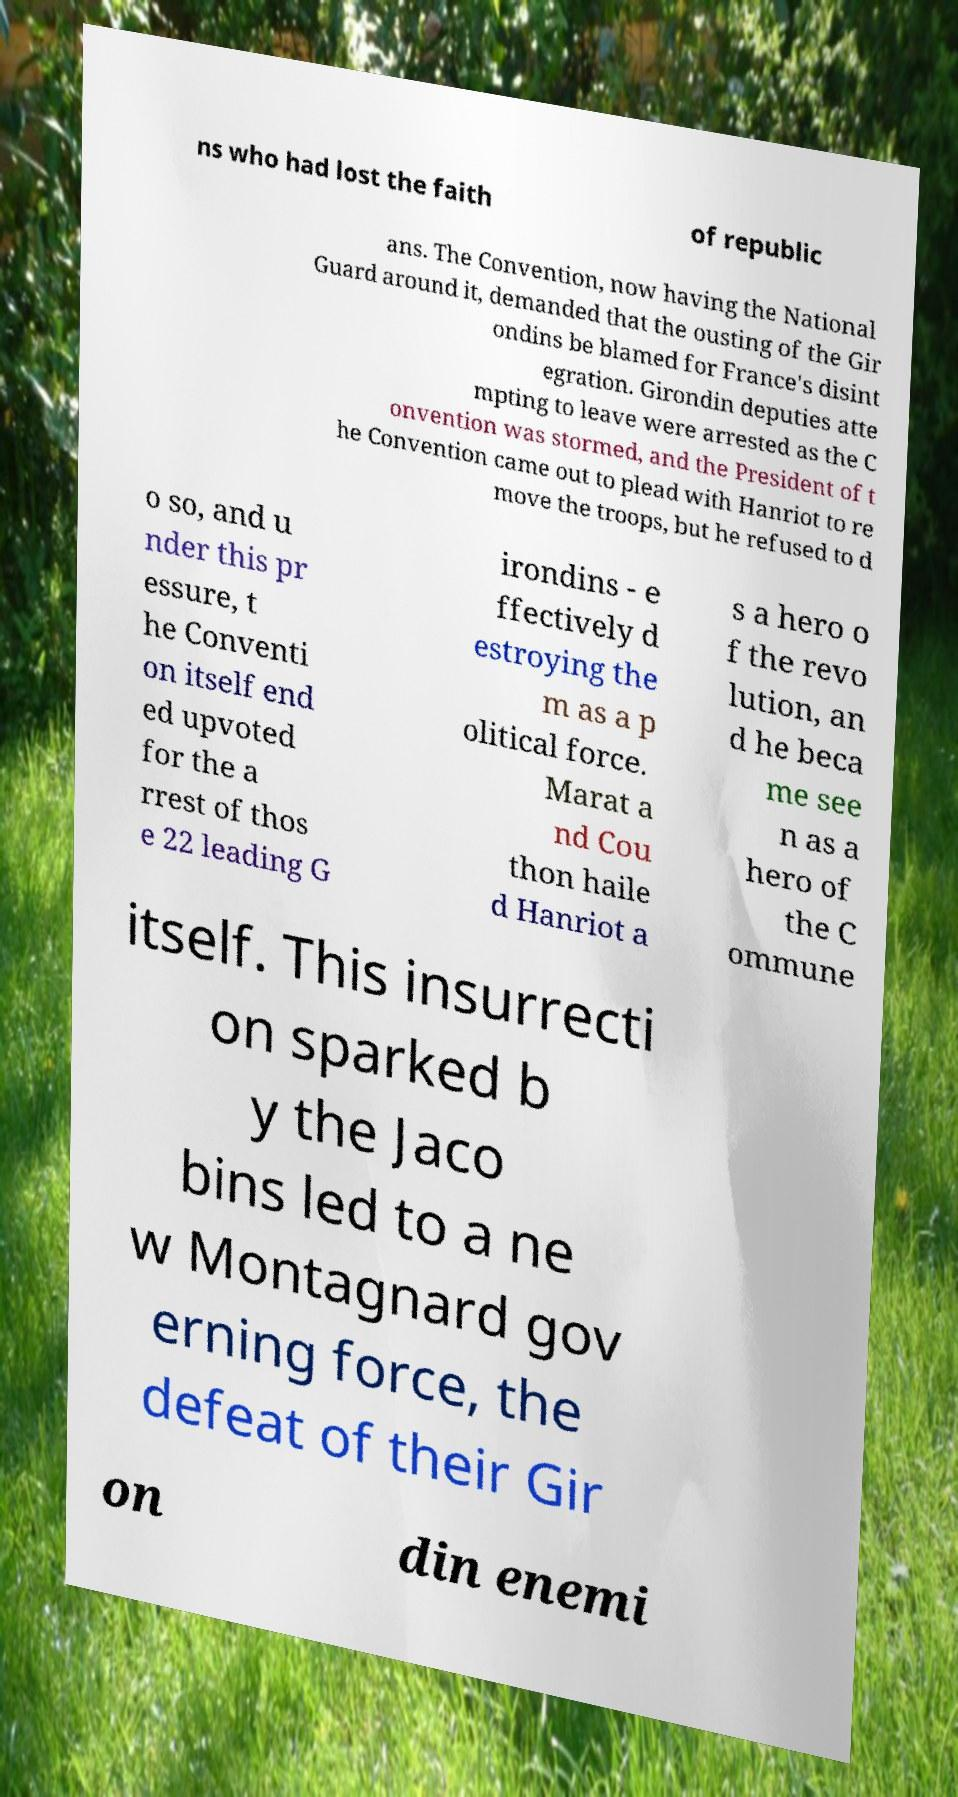Please read and relay the text visible in this image. What does it say? ns who had lost the faith of republic ans. The Convention, now having the National Guard around it, demanded that the ousting of the Gir ondins be blamed for France's disint egration. Girondin deputies atte mpting to leave were arrested as the C onvention was stormed, and the President of t he Convention came out to plead with Hanriot to re move the troops, but he refused to d o so, and u nder this pr essure, t he Conventi on itself end ed upvoted for the a rrest of thos e 22 leading G irondins - e ffectively d estroying the m as a p olitical force. Marat a nd Cou thon haile d Hanriot a s a hero o f the revo lution, an d he beca me see n as a hero of the C ommune itself. This insurrecti on sparked b y the Jaco bins led to a ne w Montagnard gov erning force, the defeat of their Gir on din enemi 